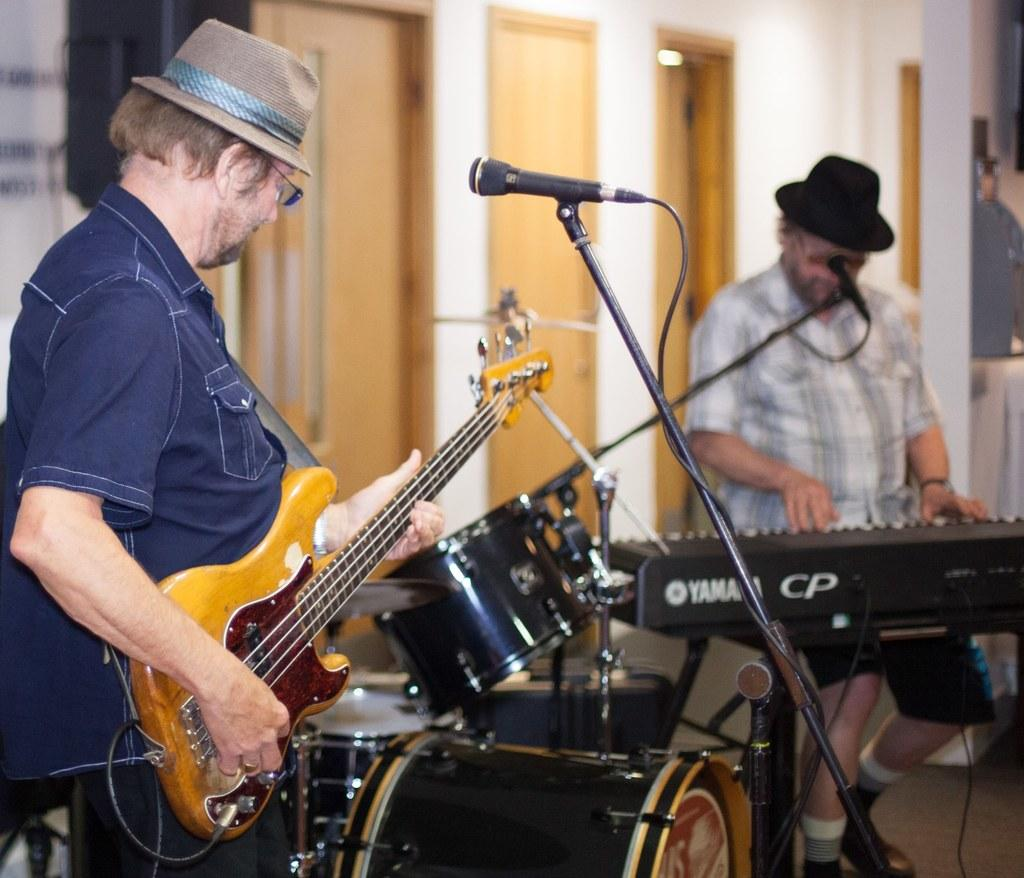How many people are in the image? There are two men in the image. What are the men doing in the image? The men are playing musical instruments. What equipment is present for amplifying sound in the image? There is a mic and stand in the image. What can be seen in the background of the image? There are doors and a wall in the background of the image. What is one of the men wearing on his head? One of the men is wearing a hat. How many dogs are visible in the image? There are no dogs present in the image. What type of form is being filled out by the men in the image? There is no form visible in the image; the men are playing musical instruments. 